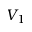Convert formula to latex. <formula><loc_0><loc_0><loc_500><loc_500>V _ { 1 }</formula> 